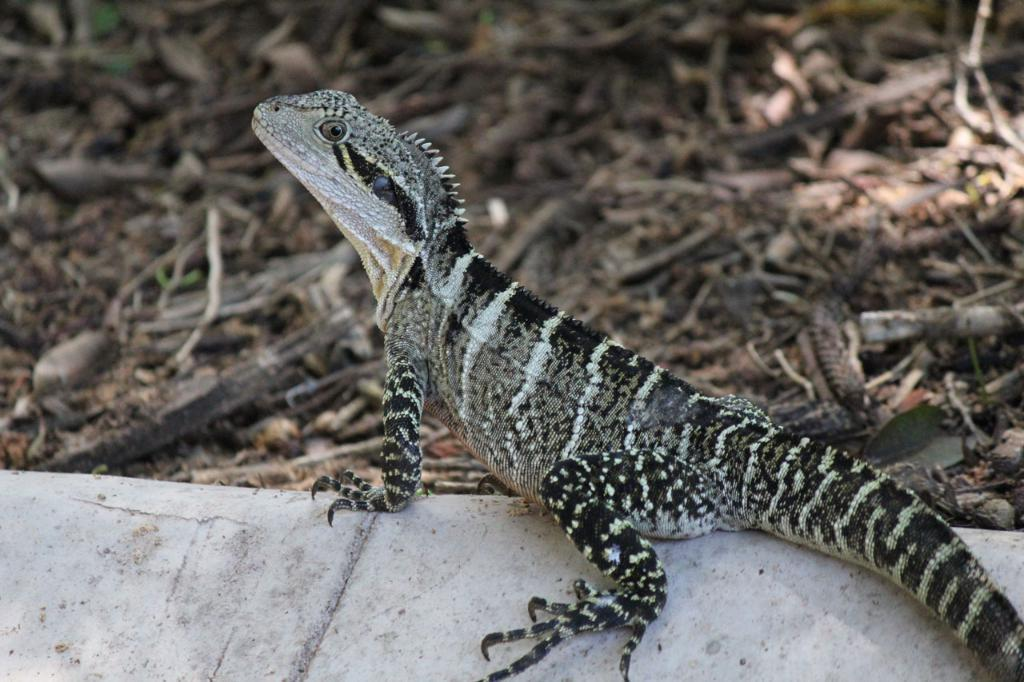What is the main subject of the image? There is a lizard in the center of the image. Where is the lizard located? The lizard is on a wall. What can be seen in the background of the image? There are stones and scrap visible in the background of the image. What type of camera can be seen in the image? There is no camera present in the image; it features a lizard on a wall with stones and scrap in the background. 